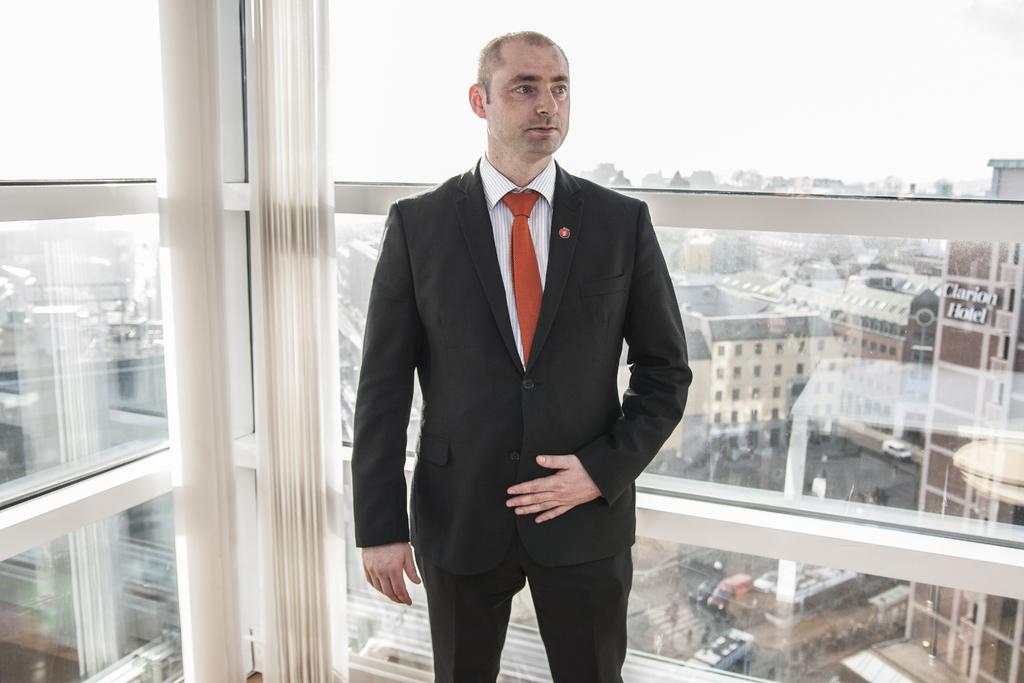What is the main subject of the image? There is a person standing in the image. What can be seen in the background of the image? There are buildings, trees, vehicles, and the sky visible in the background of the image. What type of comb is the person using in the image? There is no comb present in the image; the person is simply standing. 